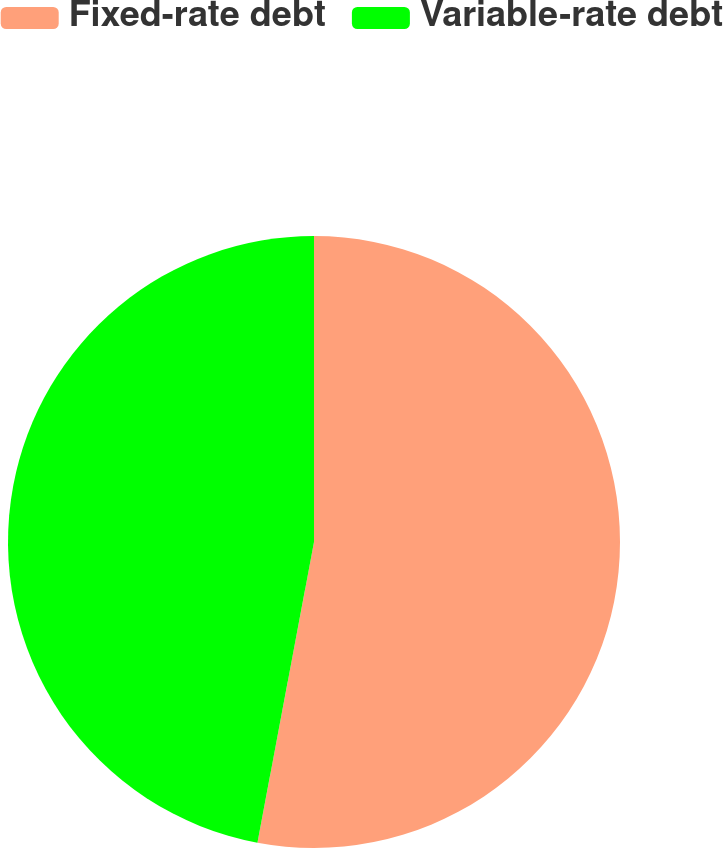Convert chart. <chart><loc_0><loc_0><loc_500><loc_500><pie_chart><fcel>Fixed-rate debt<fcel>Variable-rate debt<nl><fcel>52.96%<fcel>47.04%<nl></chart> 